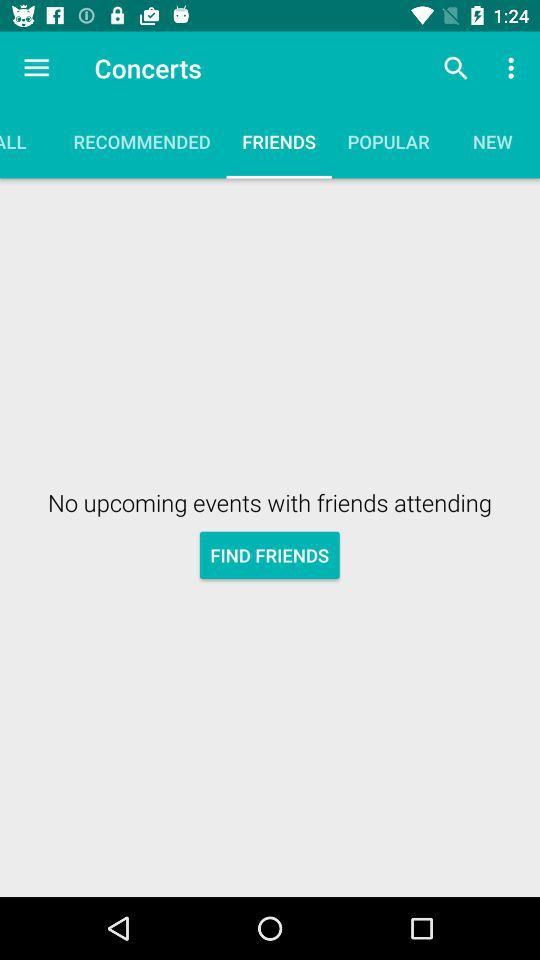What is the selected tab? The selected tab is "FRIENDS". 